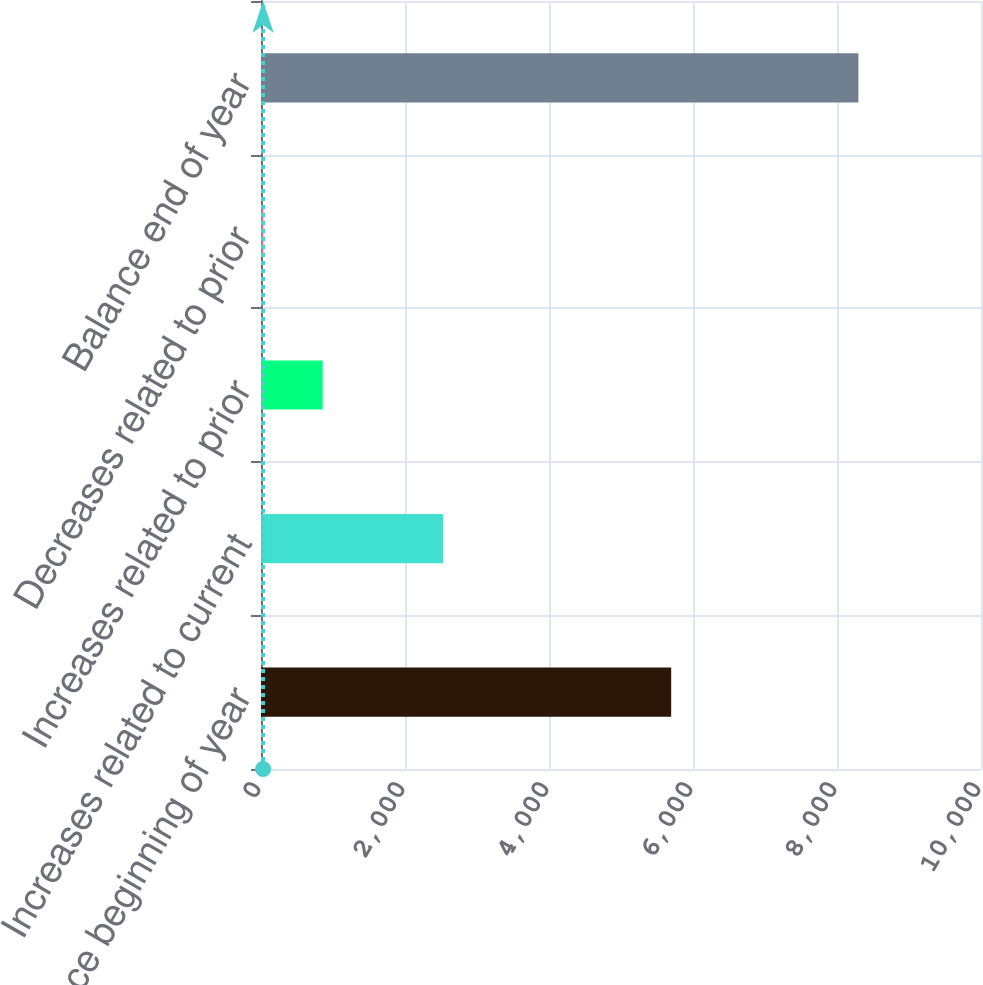Convert chart to OTSL. <chart><loc_0><loc_0><loc_500><loc_500><bar_chart><fcel>Balance beginning of year<fcel>Increases related to current<fcel>Increases related to prior<fcel>Decreases related to prior<fcel>Balance end of year<nl><fcel>5697<fcel>2528<fcel>855.8<fcel>29<fcel>8297<nl></chart> 